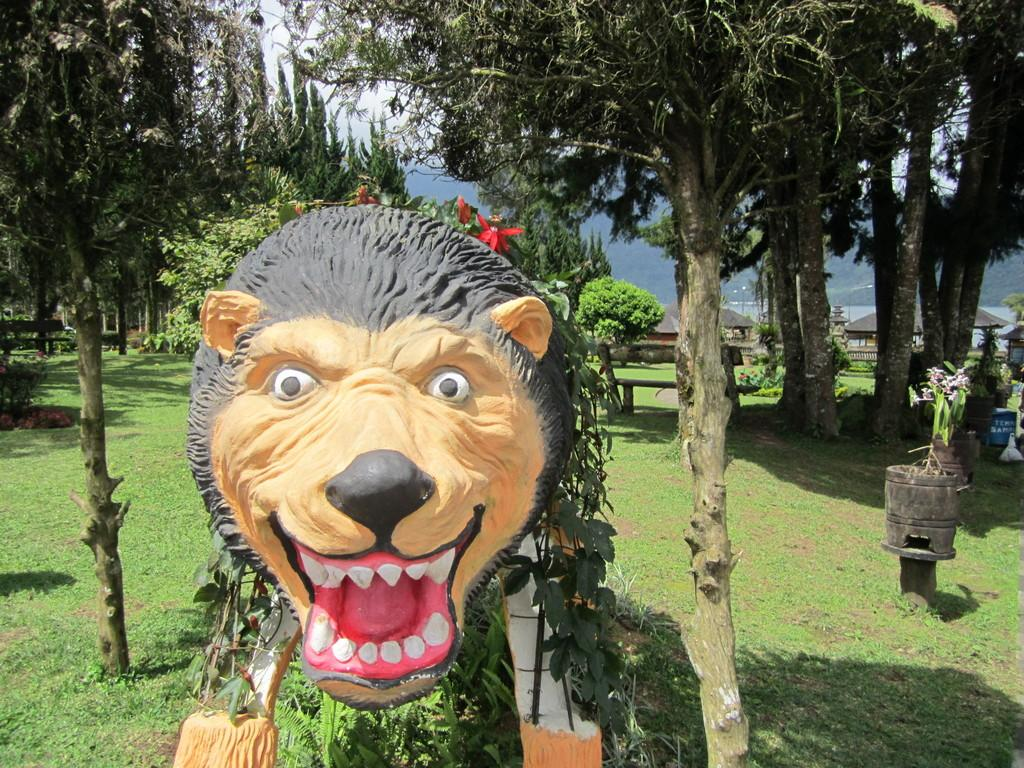What is the main subject of the image? There is a statue of an animal in the image. What type of terrain is visible in the image? There is grass on the ground in the image. What other natural elements can be seen in the image? There are trees in the image. What is visible in the background of the image? The sky is visible in the image. What language is spoken by the statue in the image? The statue is not capable of speaking any language, as it is an inanimate object. 